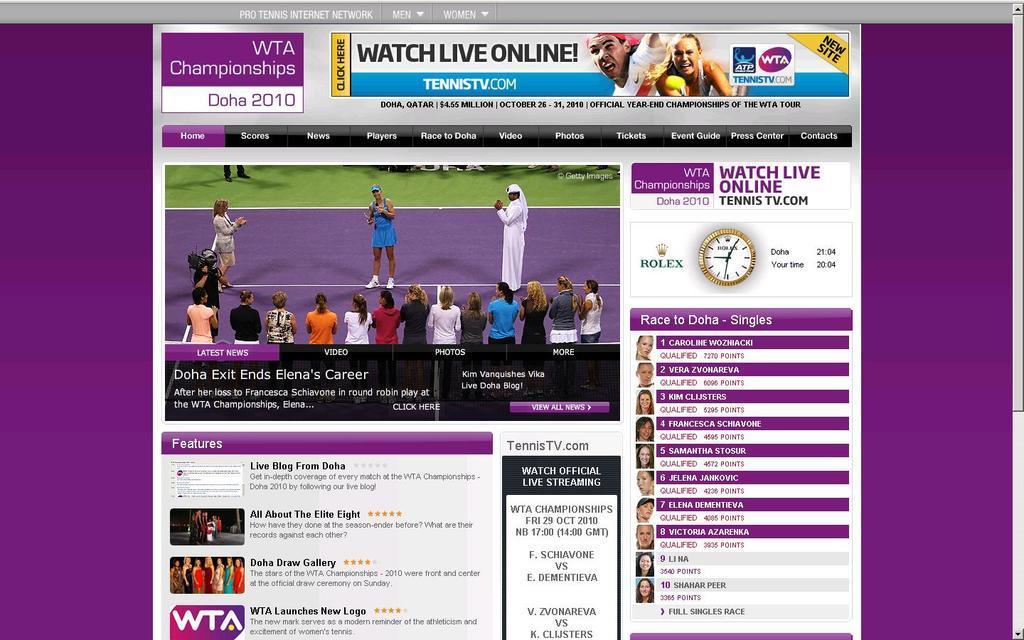Can you describe this image briefly? The image looks like a screenshot of webpage. In this picture we can see text, pictures of many people, clock and other objects. In the middle of the picture we can see the picture of a tennis court, on the court there are many people standing. In the edges of the picture we can see violet color. 